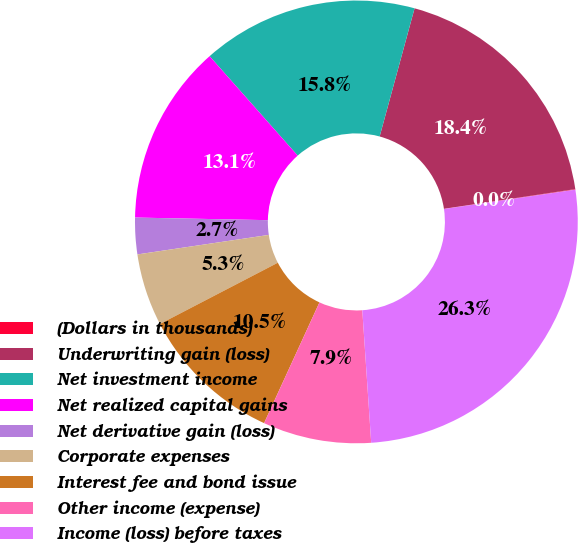<chart> <loc_0><loc_0><loc_500><loc_500><pie_chart><fcel>(Dollars in thousands)<fcel>Underwriting gain (loss)<fcel>Net investment income<fcel>Net realized capital gains<fcel>Net derivative gain (loss)<fcel>Corporate expenses<fcel>Interest fee and bond issue<fcel>Other income (expense)<fcel>Income (loss) before taxes<nl><fcel>0.04%<fcel>18.4%<fcel>15.77%<fcel>13.15%<fcel>2.66%<fcel>5.28%<fcel>10.53%<fcel>7.91%<fcel>26.26%<nl></chart> 